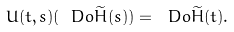<formula> <loc_0><loc_0><loc_500><loc_500>U ( t , s ) ( \ D o \widetilde { H } ( s ) ) = \ D o \widetilde { H } ( t ) .</formula> 